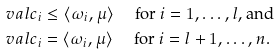Convert formula to latex. <formula><loc_0><loc_0><loc_500><loc_500>\ v a l c _ { i } & \leq \langle \omega _ { i } , \mu \rangle \quad \text { for $i=1,\dots,l$, and } \\ \ v a l c _ { i } & = \langle \omega _ { i } , \mu \rangle \quad \text { for $i=l+1,\dots,n$.}</formula> 